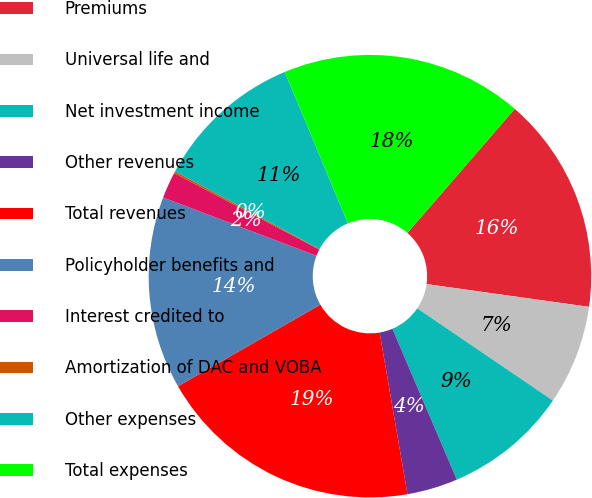Convert chart to OTSL. <chart><loc_0><loc_0><loc_500><loc_500><pie_chart><fcel>Premiums<fcel>Universal life and<fcel>Net investment income<fcel>Other revenues<fcel>Total revenues<fcel>Policyholder benefits and<fcel>Interest credited to<fcel>Amortization of DAC and VOBA<fcel>Other expenses<fcel>Total expenses<nl><fcel>15.86%<fcel>7.29%<fcel>9.07%<fcel>3.71%<fcel>19.43%<fcel>14.07%<fcel>1.93%<fcel>0.14%<fcel>10.86%<fcel>17.64%<nl></chart> 